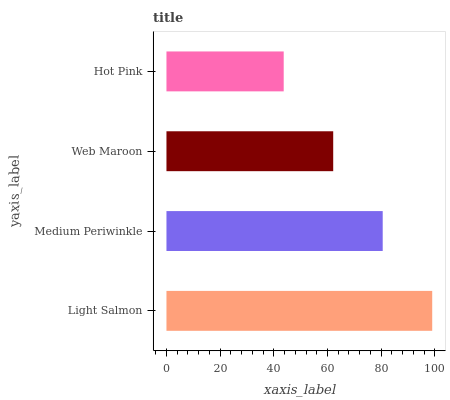Is Hot Pink the minimum?
Answer yes or no. Yes. Is Light Salmon the maximum?
Answer yes or no. Yes. Is Medium Periwinkle the minimum?
Answer yes or no. No. Is Medium Periwinkle the maximum?
Answer yes or no. No. Is Light Salmon greater than Medium Periwinkle?
Answer yes or no. Yes. Is Medium Periwinkle less than Light Salmon?
Answer yes or no. Yes. Is Medium Periwinkle greater than Light Salmon?
Answer yes or no. No. Is Light Salmon less than Medium Periwinkle?
Answer yes or no. No. Is Medium Periwinkle the high median?
Answer yes or no. Yes. Is Web Maroon the low median?
Answer yes or no. Yes. Is Web Maroon the high median?
Answer yes or no. No. Is Medium Periwinkle the low median?
Answer yes or no. No. 